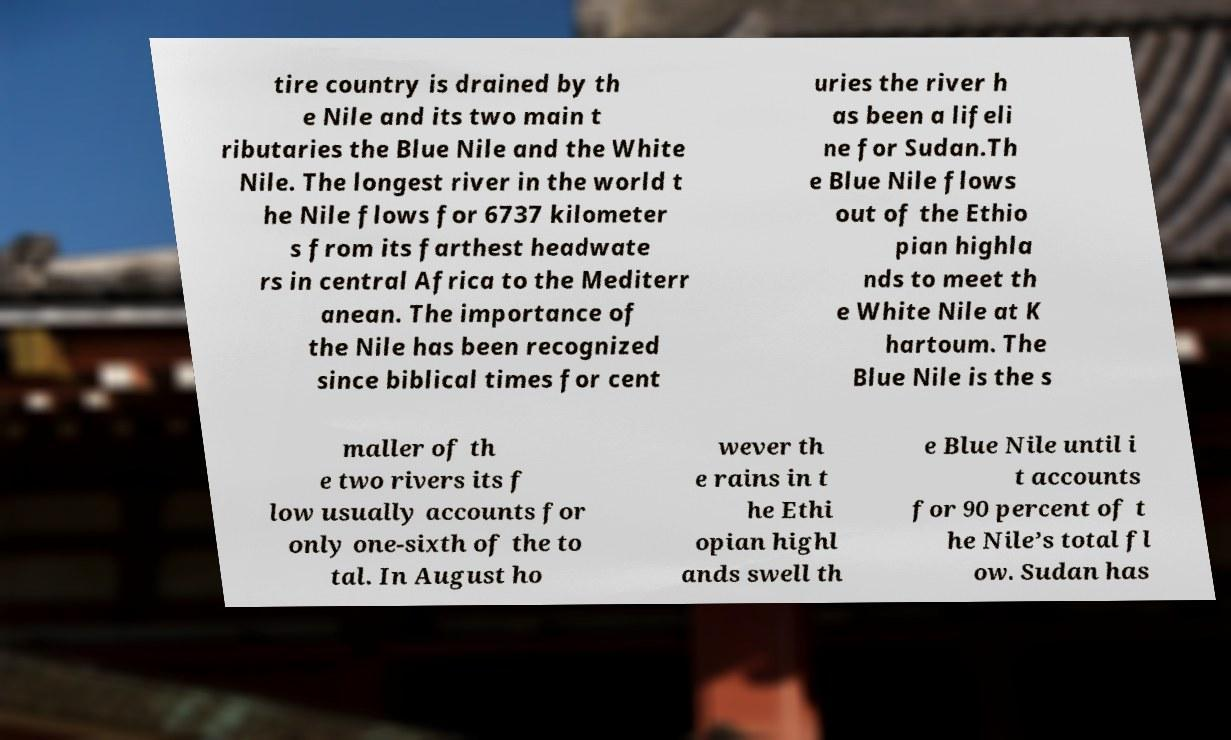Can you accurately transcribe the text from the provided image for me? tire country is drained by th e Nile and its two main t ributaries the Blue Nile and the White Nile. The longest river in the world t he Nile flows for 6737 kilometer s from its farthest headwate rs in central Africa to the Mediterr anean. The importance of the Nile has been recognized since biblical times for cent uries the river h as been a lifeli ne for Sudan.Th e Blue Nile flows out of the Ethio pian highla nds to meet th e White Nile at K hartoum. The Blue Nile is the s maller of th e two rivers its f low usually accounts for only one-sixth of the to tal. In August ho wever th e rains in t he Ethi opian highl ands swell th e Blue Nile until i t accounts for 90 percent of t he Nile’s total fl ow. Sudan has 